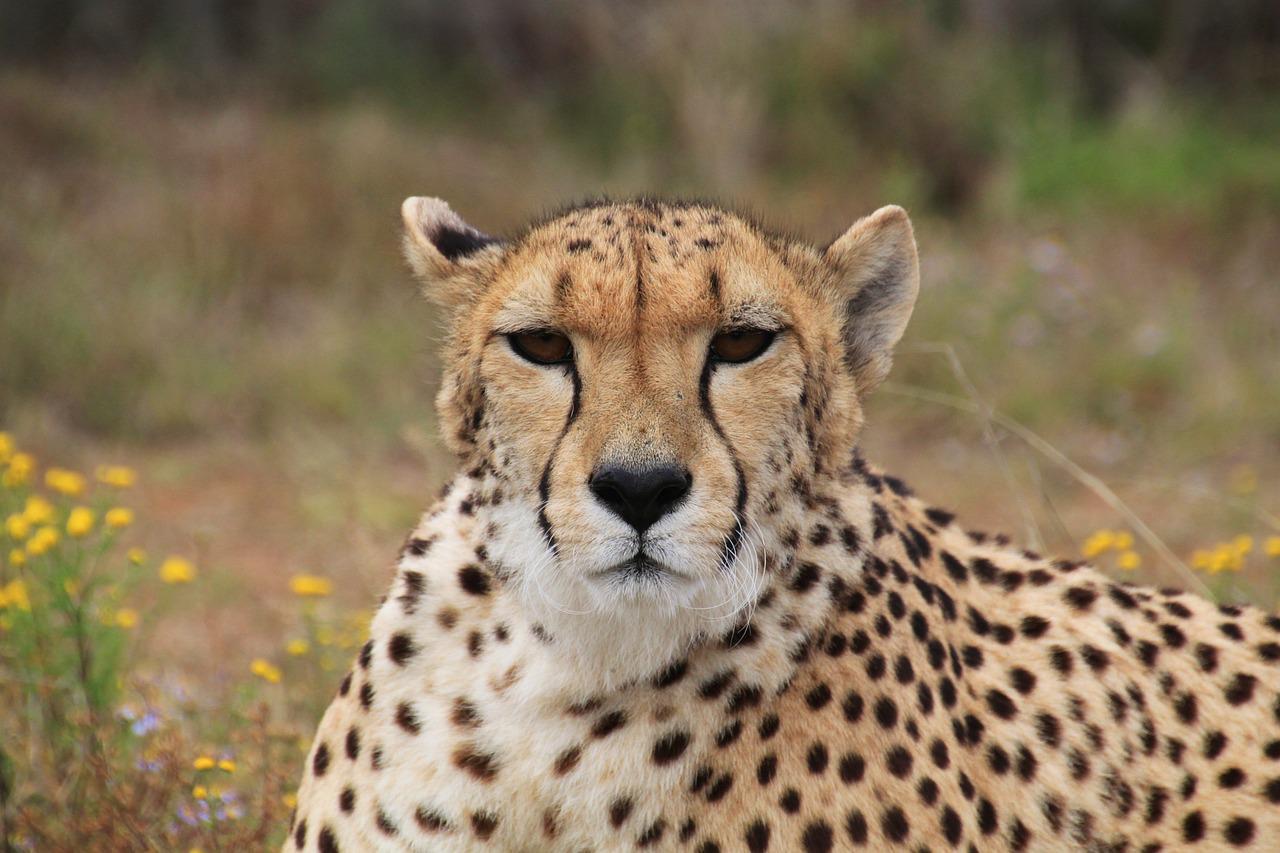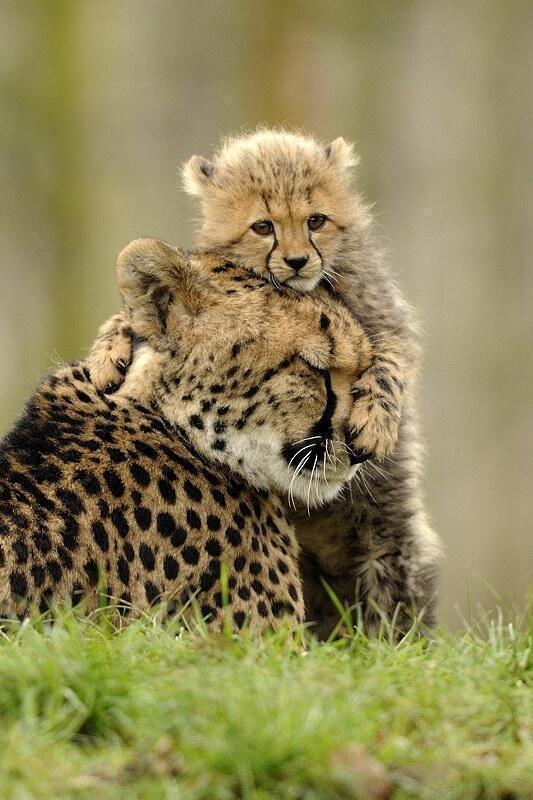The first image is the image on the left, the second image is the image on the right. Given the left and right images, does the statement "A cheetah is yawning." hold true? Answer yes or no. No. The first image is the image on the left, the second image is the image on the right. For the images displayed, is the sentence "the right pic has two cheetahs" factually correct? Answer yes or no. Yes. 